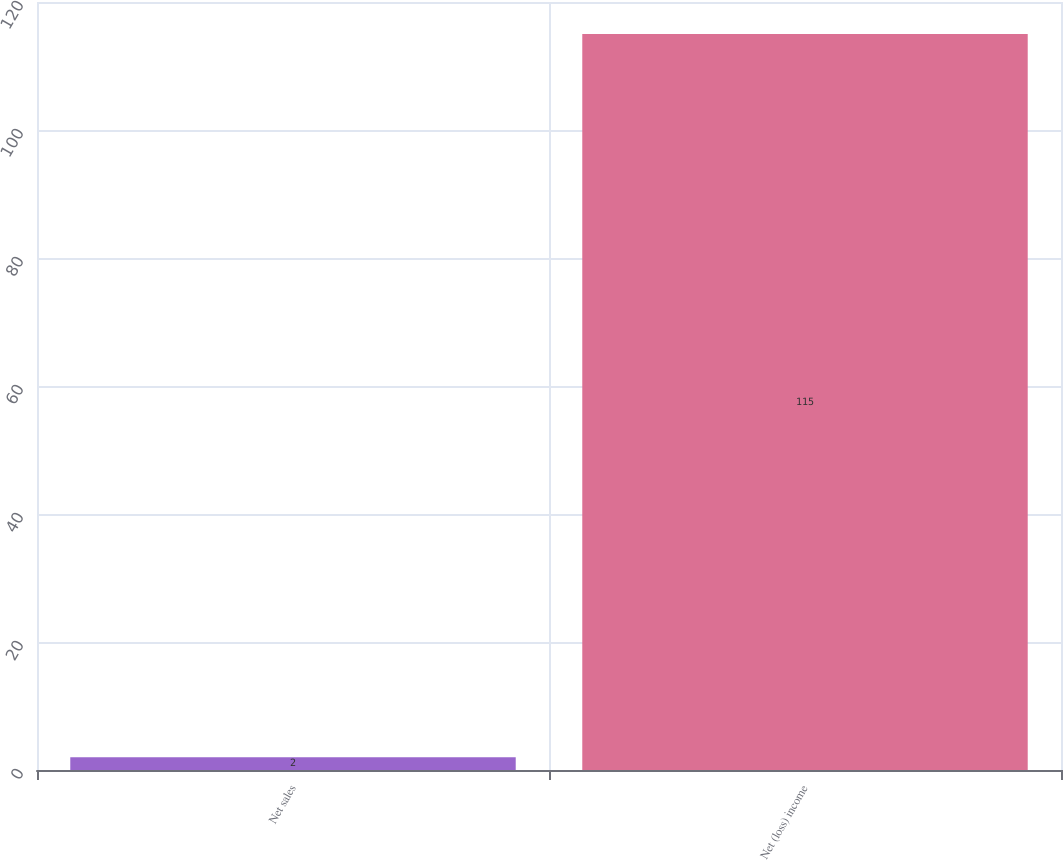Convert chart to OTSL. <chart><loc_0><loc_0><loc_500><loc_500><bar_chart><fcel>Net sales<fcel>Net (loss) income<nl><fcel>2<fcel>115<nl></chart> 